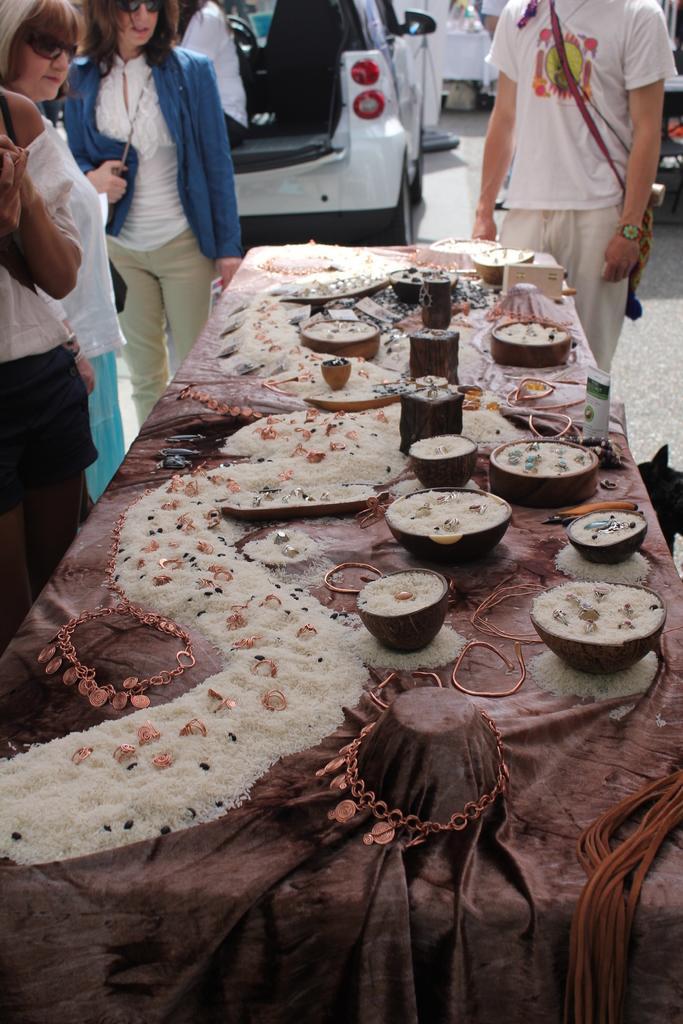In one or two sentences, can you explain what this image depicts? The photo is taken in the middle of a road. On a table there are grains,chains,bowls. Few people are standing around the table. In the background there are cars and people. 